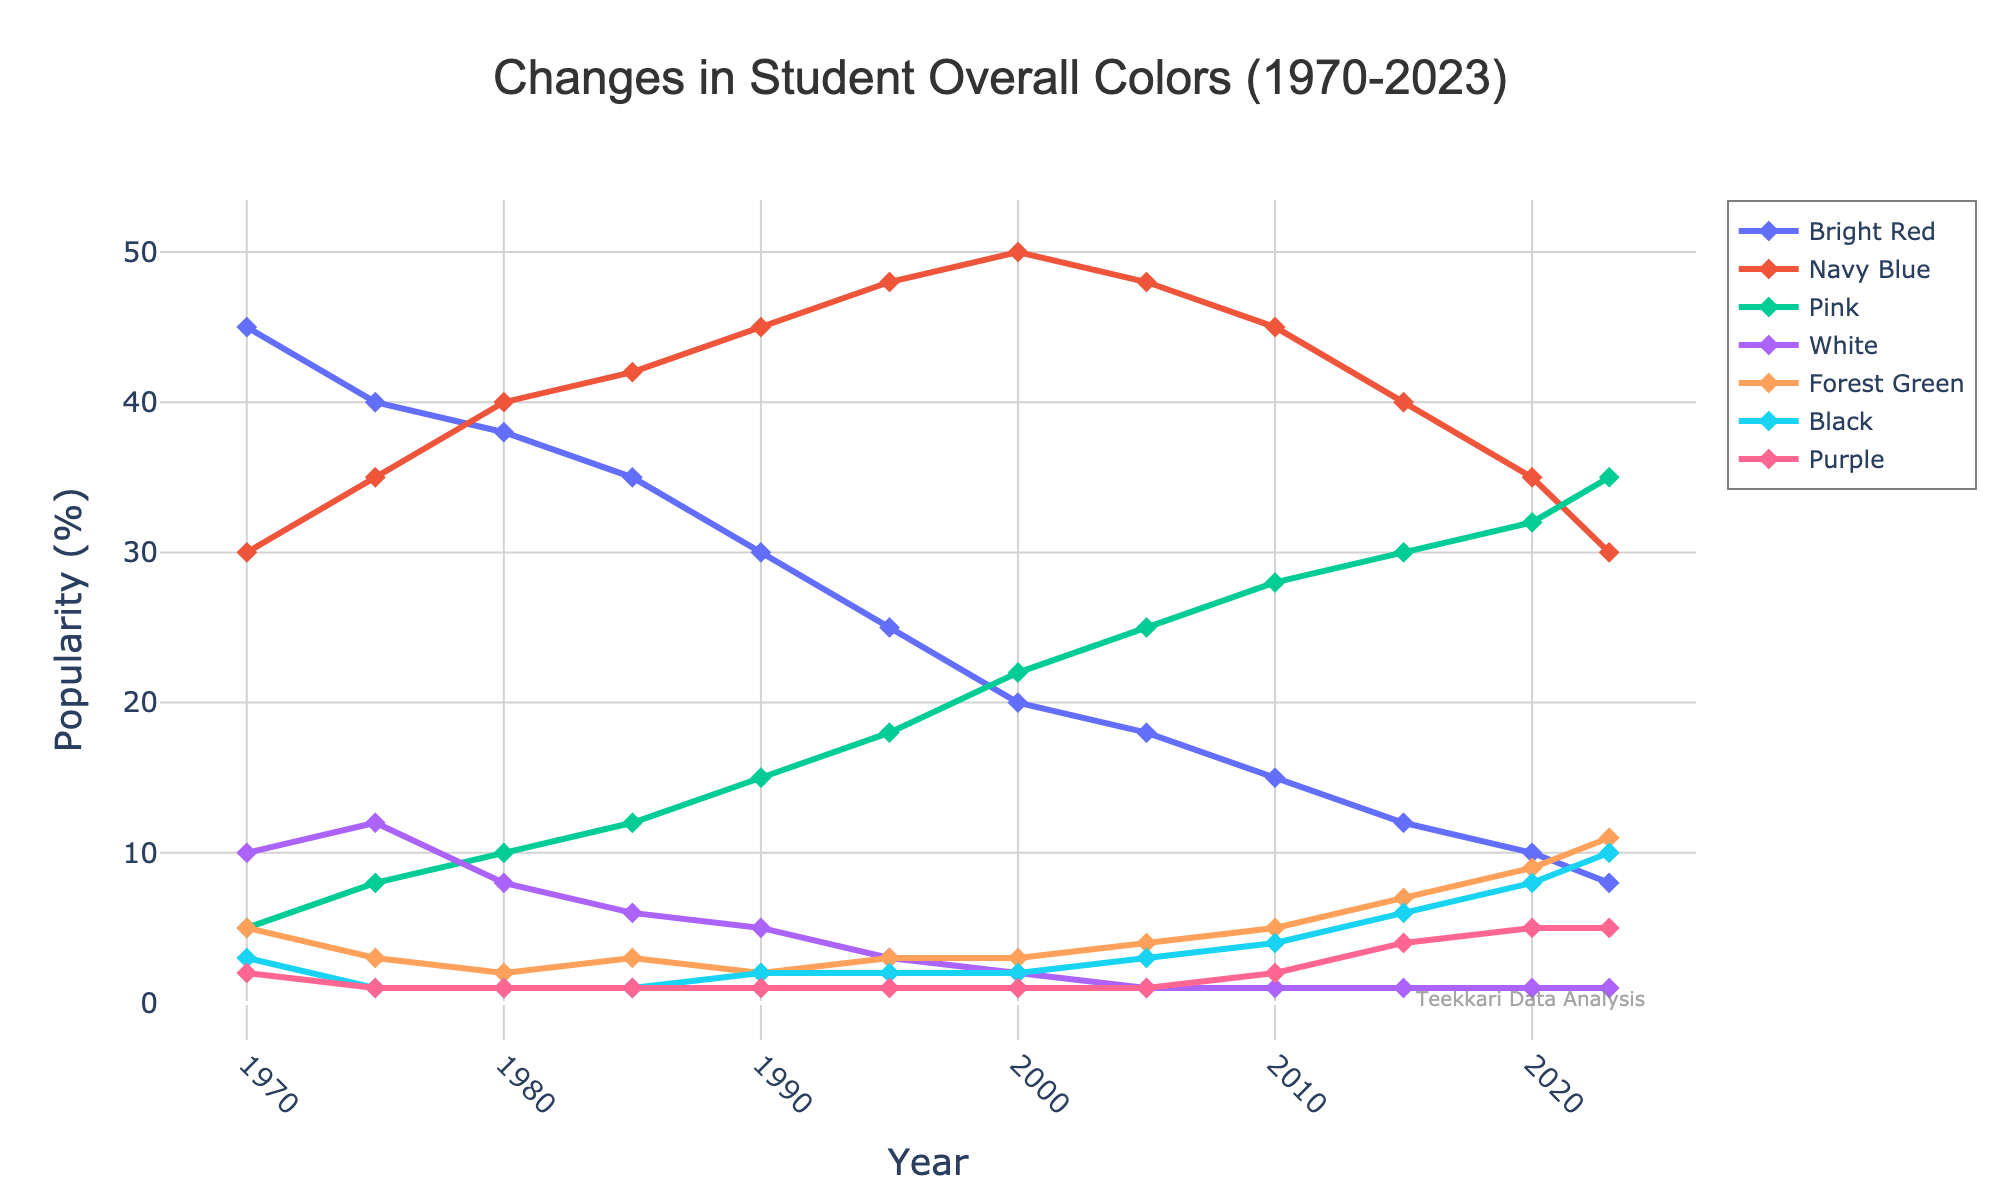What year did Navy Blue surpass Bright Red in popularity for the first time? To determine this, look at the intersection point between the Navy Blue and Bright Red lines. Navy Blue surpassed Bright Red between 1970 and 1975
Answer: 1975 Which color showed the highest increase in popularity from 1970 to 2023? Calculate the difference in popularity for each color between 1970 and 2023. Pink increased from 5% to 35%, which is an increase of 30%. Compare it to other increases, the highest is Pink
Answer: Pink What was the popularity of Forest Green in 2020 compared to Bright Red in 1975? Check the figure for Forest Green at the year 2020 (9%) and Bright Red at year 1975 (40%)
Answer: Forest Green: 9%, Bright Red: 40% Between which two years did the popularity of Black see the most significant increase? Observe the steepest rise for Black on the figure. The segment between 2010 (4%) and 2015 (6%) has a noticeable increase
Answer: 2010-2015 Which overall color had the least popularity in 1980 and has it ever surpassed 5% in any other year? In 1980, Black and Purple both had 1% popularity, making them the least. Purple has not surpassed 5% in any other year. Verify if Black has ever surpassed it; it's even below 5% in all years
Answer: Purple, No How does the popularity trend of Pink compare to that of Bright Red from 1970 to 2023? Observe the general trend: Pink consistently rises from 1970 (5%) to 2023 (35%), while Bright Red decreases from 45% to 8%. Compare these opposing trends
Answer: Pink: Increasing, Bright Red: Decreasing Which year shows the closest popularity values between White and Forest Green? Find the years where the percent values for White and Forest Green are nearest. In 2023, White is 1% and Forest Green is 11%, in 1975, White is 12% and Forest Green is 3%, but in 1990, White is 5% and Forest Green is 2%
Answer: 1990 What is the average popularity of Navy Blue between the years 1990 and 2010? Identify values for Navy Blue in years 1990, 1995, 2000, 2005, 2010, and then calculate the average: (45% + 48% + 50% + 48% + 45%) / 5
Answer: 47.2% Has there ever been a year when Navy Blue and Bright Red have the same popularity? Look for overlapping points between Navy Blue and Bright Red lines. They never intersect, confirming different values throughout the years
Answer: No 